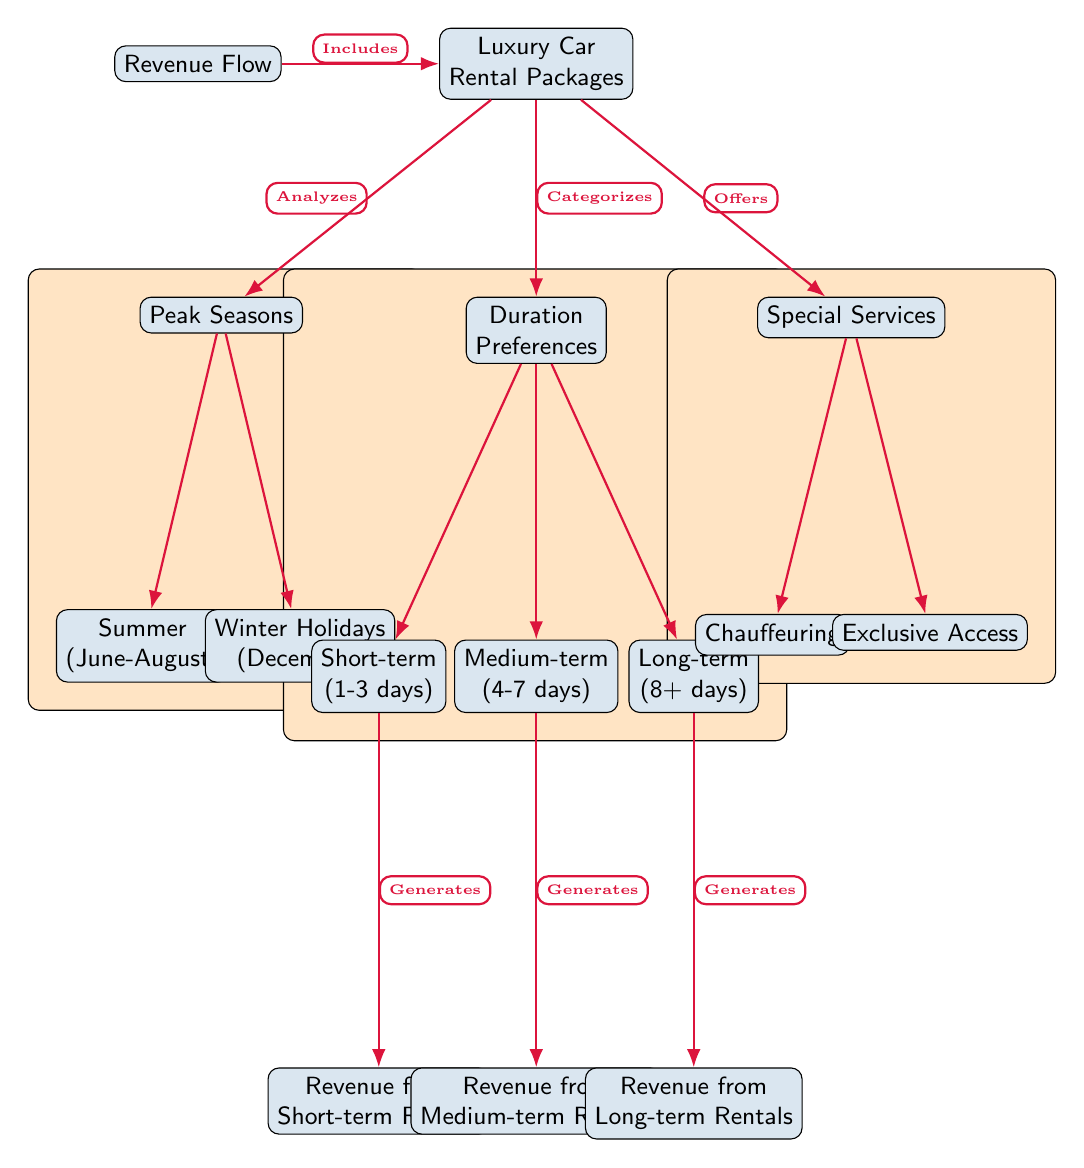What are the main categories of luxury car rental packages? The diagram identifies three main categories of luxury car rental packages: Peak Seasons, Duration Preferences, and Special Services. These categories are represented as nodes connected to the main package node.
Answer: Peak Seasons, Duration Preferences, Special Services How many peak seasons are illustrated in the diagram? The diagram indicates two peak seasons: Summer (June-August) and Winter Holidays (December). Both are drawn as nodes directly connected to the Peak Seasons node.
Answer: 2 What generates revenue from medium-term rentals? The medium-term node is directly connected to the revenue node through a labeled edge that states it generates revenue from medium-term rentals.
Answer: Revenue from Medium-term Rentals Which special service is mentioned in the diagram? The special services node has two labeled edges, of which one is Chauffeuring. This service is listed as a node beneath the Special Services category.
Answer: Chauffeuring What is the shortest rental duration represented in the diagram? The diagram categorizes rental durations into short-term, medium-term, and long-term. The shortest duration indicated is Short-term, which refers to 1-3 days.
Answer: Short-term (1-3 days) Which categories analyze luxury car rental packages? The diagram shows that the package node analyzes luxury car rental packages through the Peak Seasons and Duration Preferences nodes. These connections depict the flow of analysis.
Answer: Peak Seasons, Duration Preferences How many nodes are represented under Duration Preferences? Under Duration Preferences, there are three nodes: Short-term, Medium-term, and Long-term. Thus, the total count of nodes here is three.
Answer: 3 What type of diagram is being used to illustrate the revenue flow? The structure and style of the diagram indicate that it is a textbook diagram, which is typically used for educational purposes and detailed explanations of subjects.
Answer: Textbook Diagram 